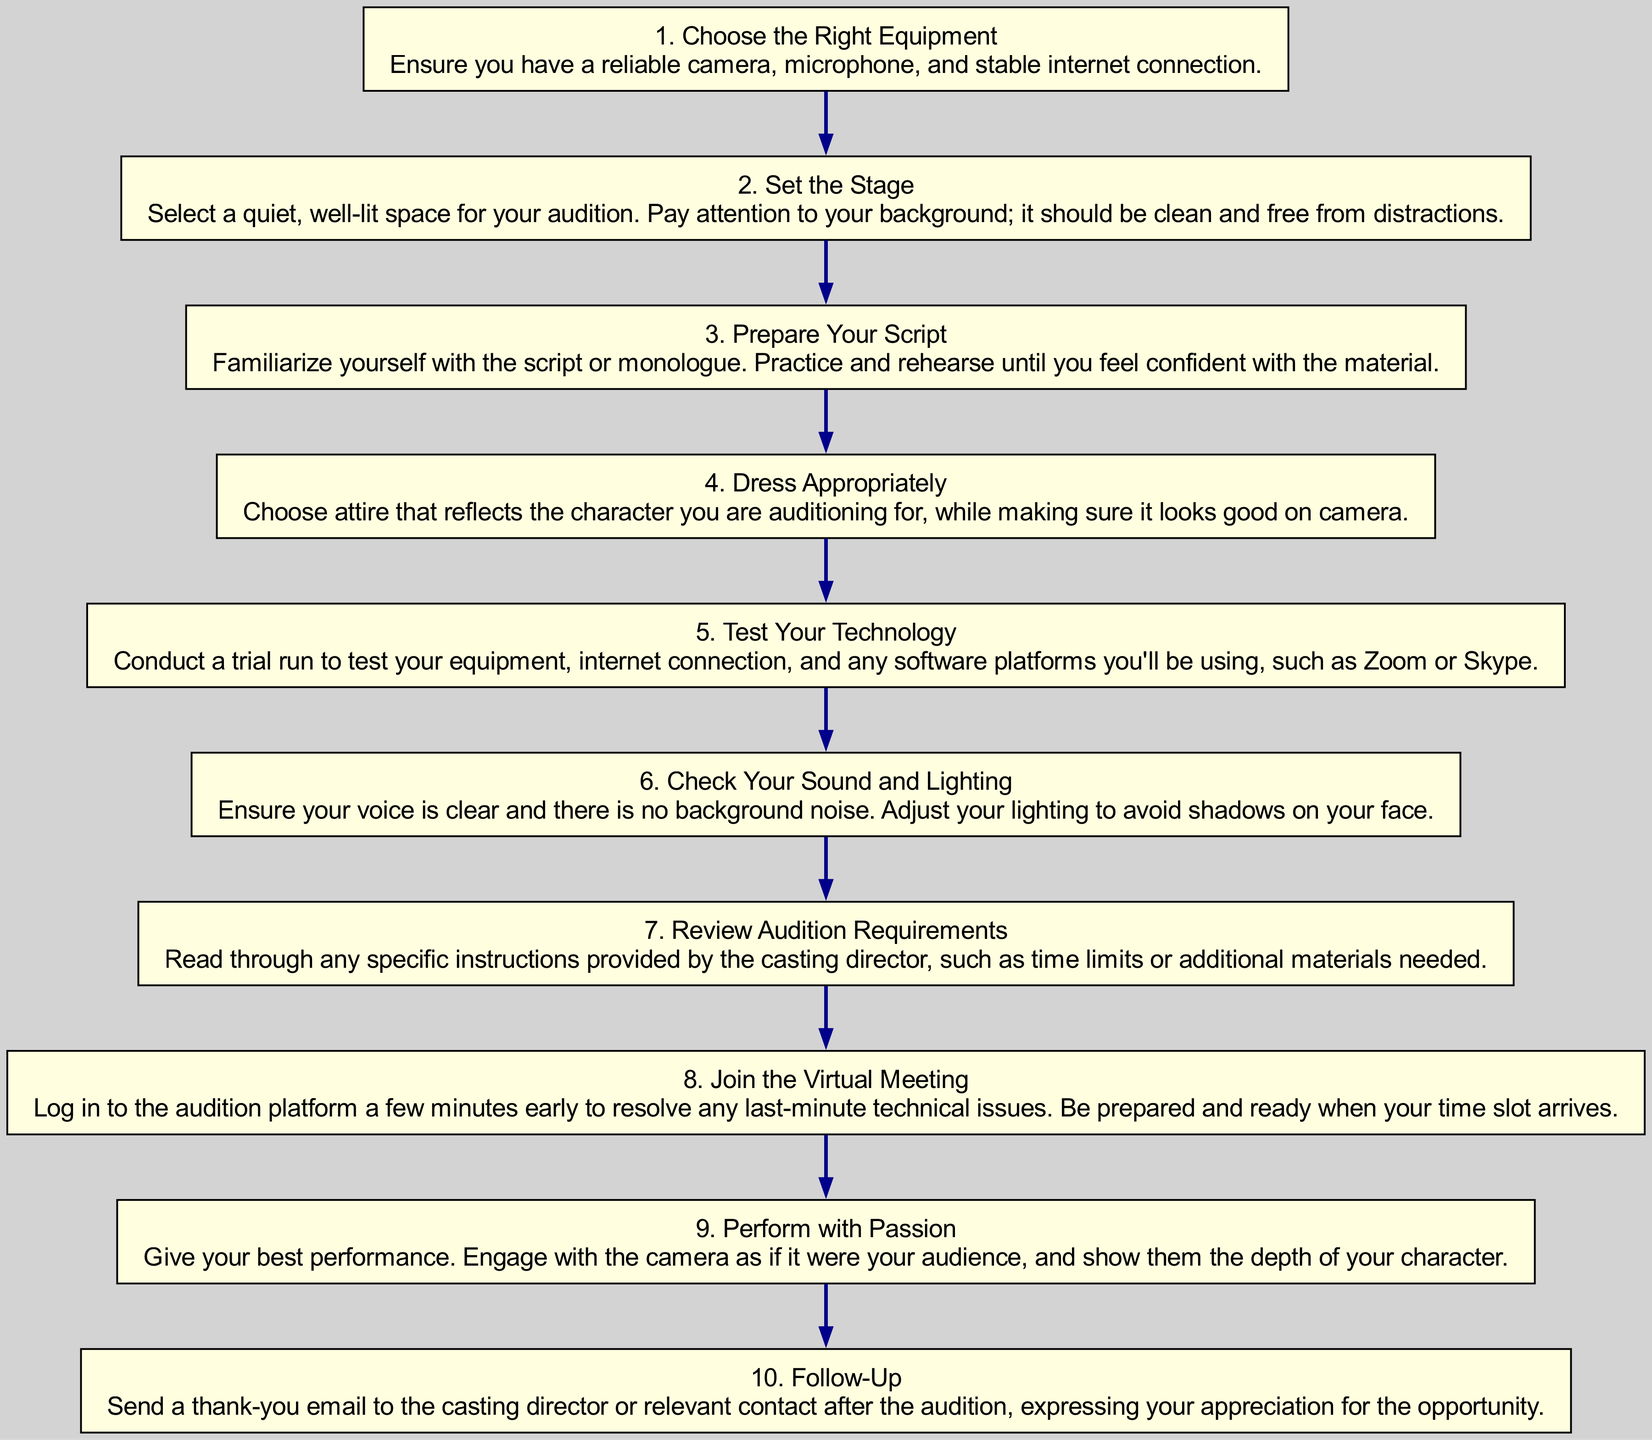What is the first step in the diagram? The first step is labeled as "1. Choose the Right Equipment," which is the initial action to start the virtual audition preparation process.
Answer: Choose the Right Equipment How many steps are there in total? By counting the individual steps listed in the diagram, we can identify that there are ten distinct steps included in the flowchart.
Answer: 10 What does the sixth step entail? The sixth step is titled "6. Check Your Sound and Lighting," which emphasizes the importance of having clear audio and proper lighting during the audition.
Answer: Check Your Sound and Lighting What is the relationship between "Test Your Technology" and "Join the Virtual Meeting"? The steps are sequential; "Test Your Technology" must be completed before "Join the Virtual Meeting" to ensure that all equipment is functioning correctly ahead of the audition.
Answer: Sequential Which step directly follows "Dressing Appropriately"? The step that directly follows "Dressing Appropriately" is "Test Your Technology," indicating a specific order to prepare for the audition.
Answer: Test Your Technology In total, how many actions focus on technology? There are three steps related to technology: "Test Your Technology," "Check Your Sound and Lighting," and "Join the Virtual Meeting," all emphasizing the technical aspects needed for a successful audition.
Answer: 3 What is the last step in the flowchart? The last step is "10. Follow-Up," which suggests sending a thank-you email after the audition as an important concluding action.
Answer: Follow-Up Which step includes preparing a script? The step that covers preparing a script is "3. Prepare Your Script," which highlights the need to rehearse the material before the audition.
Answer: Prepare Your Script What kind of space should you select for the audition according to the diagram? The diagram specifies a "quiet, well-lit space" for the audition, indicating ideal conditions for a successful performance.
Answer: Quiet, well-lit space 